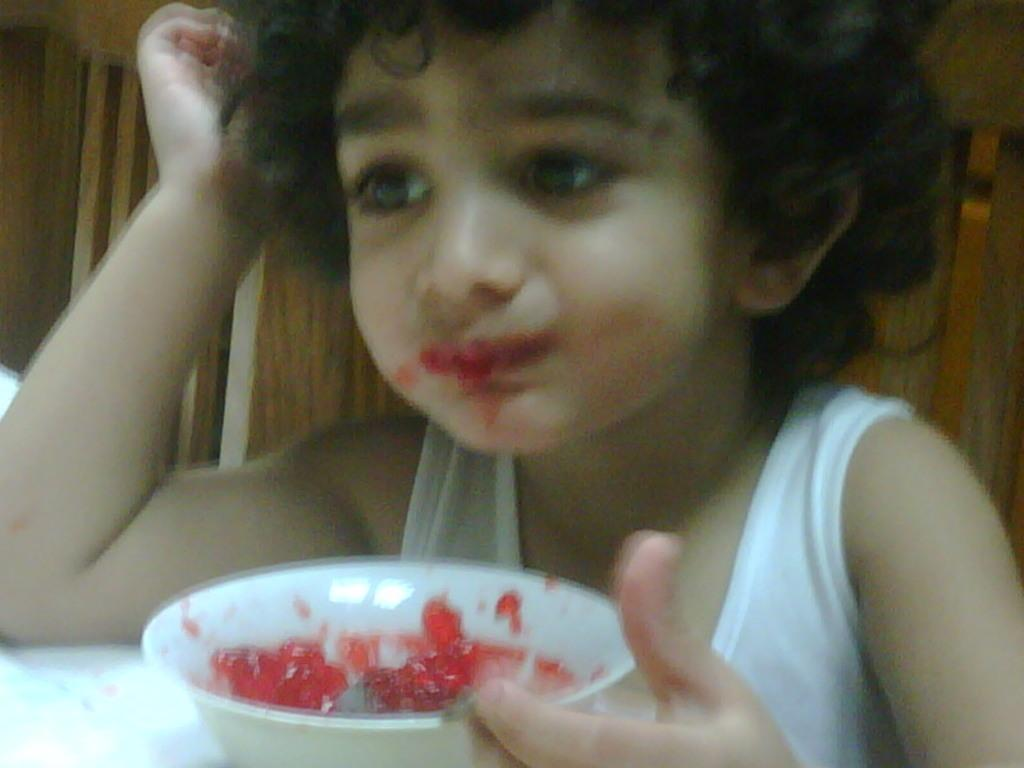What is the main subject of the image? The main subject of the image is a kid. What is the kid doing in the image? The kid is sitting and eating jam. What color is the bowl in the image? The bowl is white in color. What is in the bowl that the kid is eating? The bowl contains red color jam. What is the kid's reason for not wanting to go on a boat ride in the image? There is no mention of boats or boat rides in the image, so it is not possible to determine the kid's reason for not wanting to go on a boat ride. 